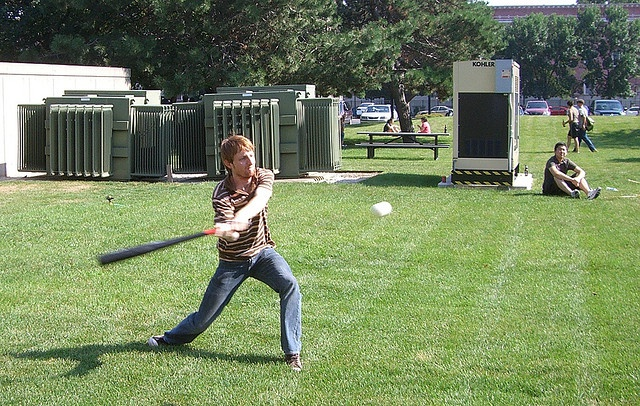Describe the objects in this image and their specific colors. I can see people in black, white, and gray tones, people in black, gray, white, and darkgray tones, bench in black, gray, darkgray, and olive tones, baseball bat in black, gray, and darkgray tones, and people in black, gray, lightgray, and darkgreen tones in this image. 